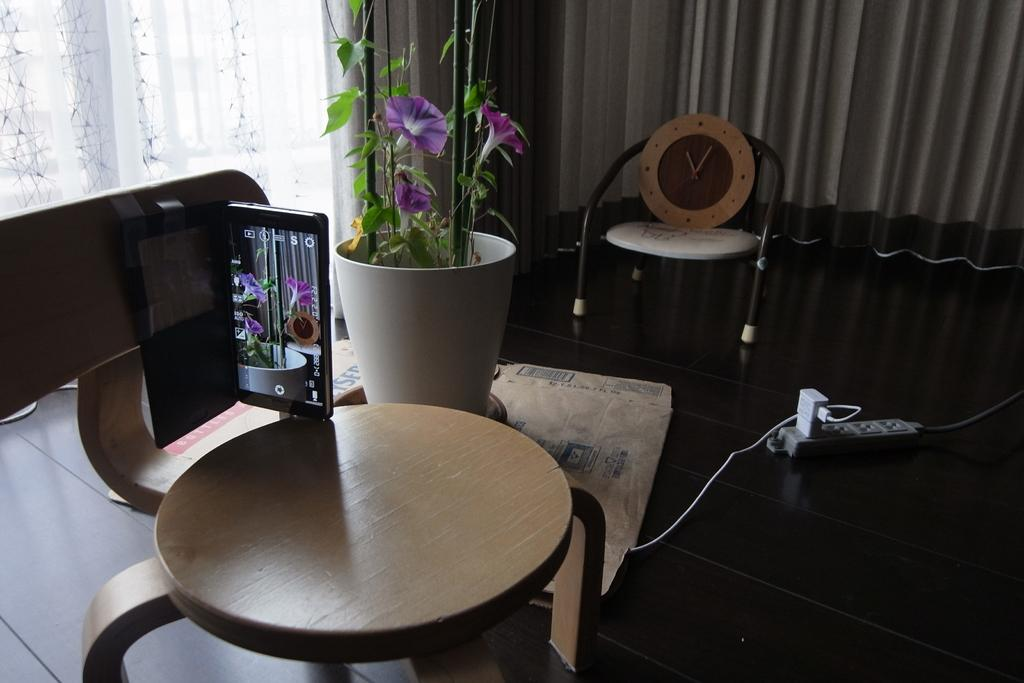What can be seen in the background of the image? There are curtains in the background of the image. What is placed on the clock is placed on in the image? The clock is on a chair in the image. What else is on the chair besides the clock? There is a mobile on the chair. Can you describe the flower pot in the image? There is a flower pot in the image. What electronic items are visible on the floor? An adapter and charger are visible on the floor. What type of brass instrument is being played by the band in the image? There is no band or brass instrument present in the image. What color is the flower pot in the image? The provided facts do not mention the color of the flower pot, so we cannot definitively answer this question. 